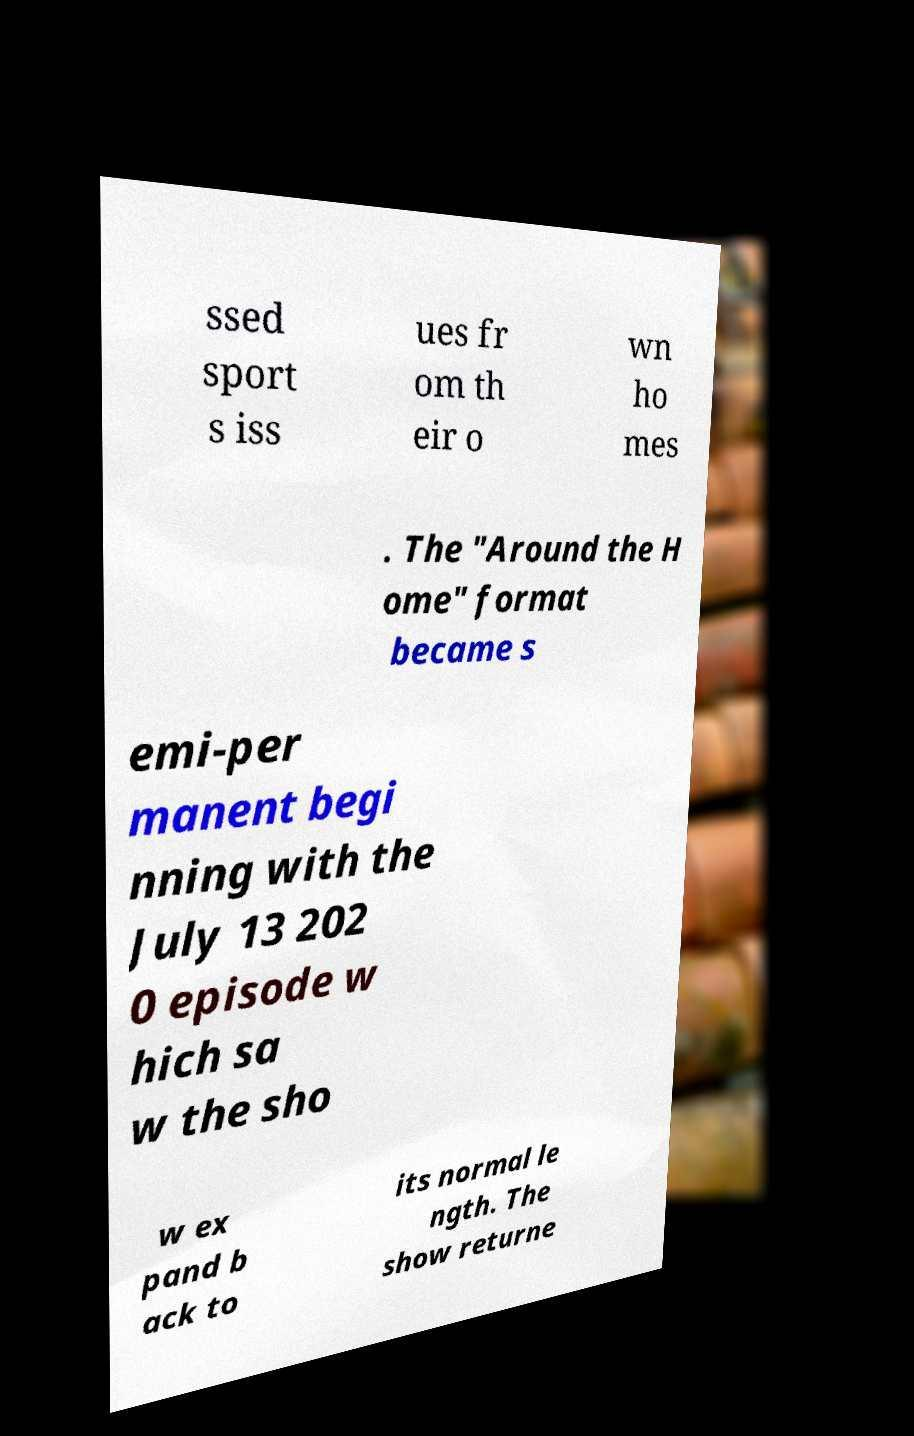I need the written content from this picture converted into text. Can you do that? ssed sport s iss ues fr om th eir o wn ho mes . The "Around the H ome" format became s emi-per manent begi nning with the July 13 202 0 episode w hich sa w the sho w ex pand b ack to its normal le ngth. The show returne 